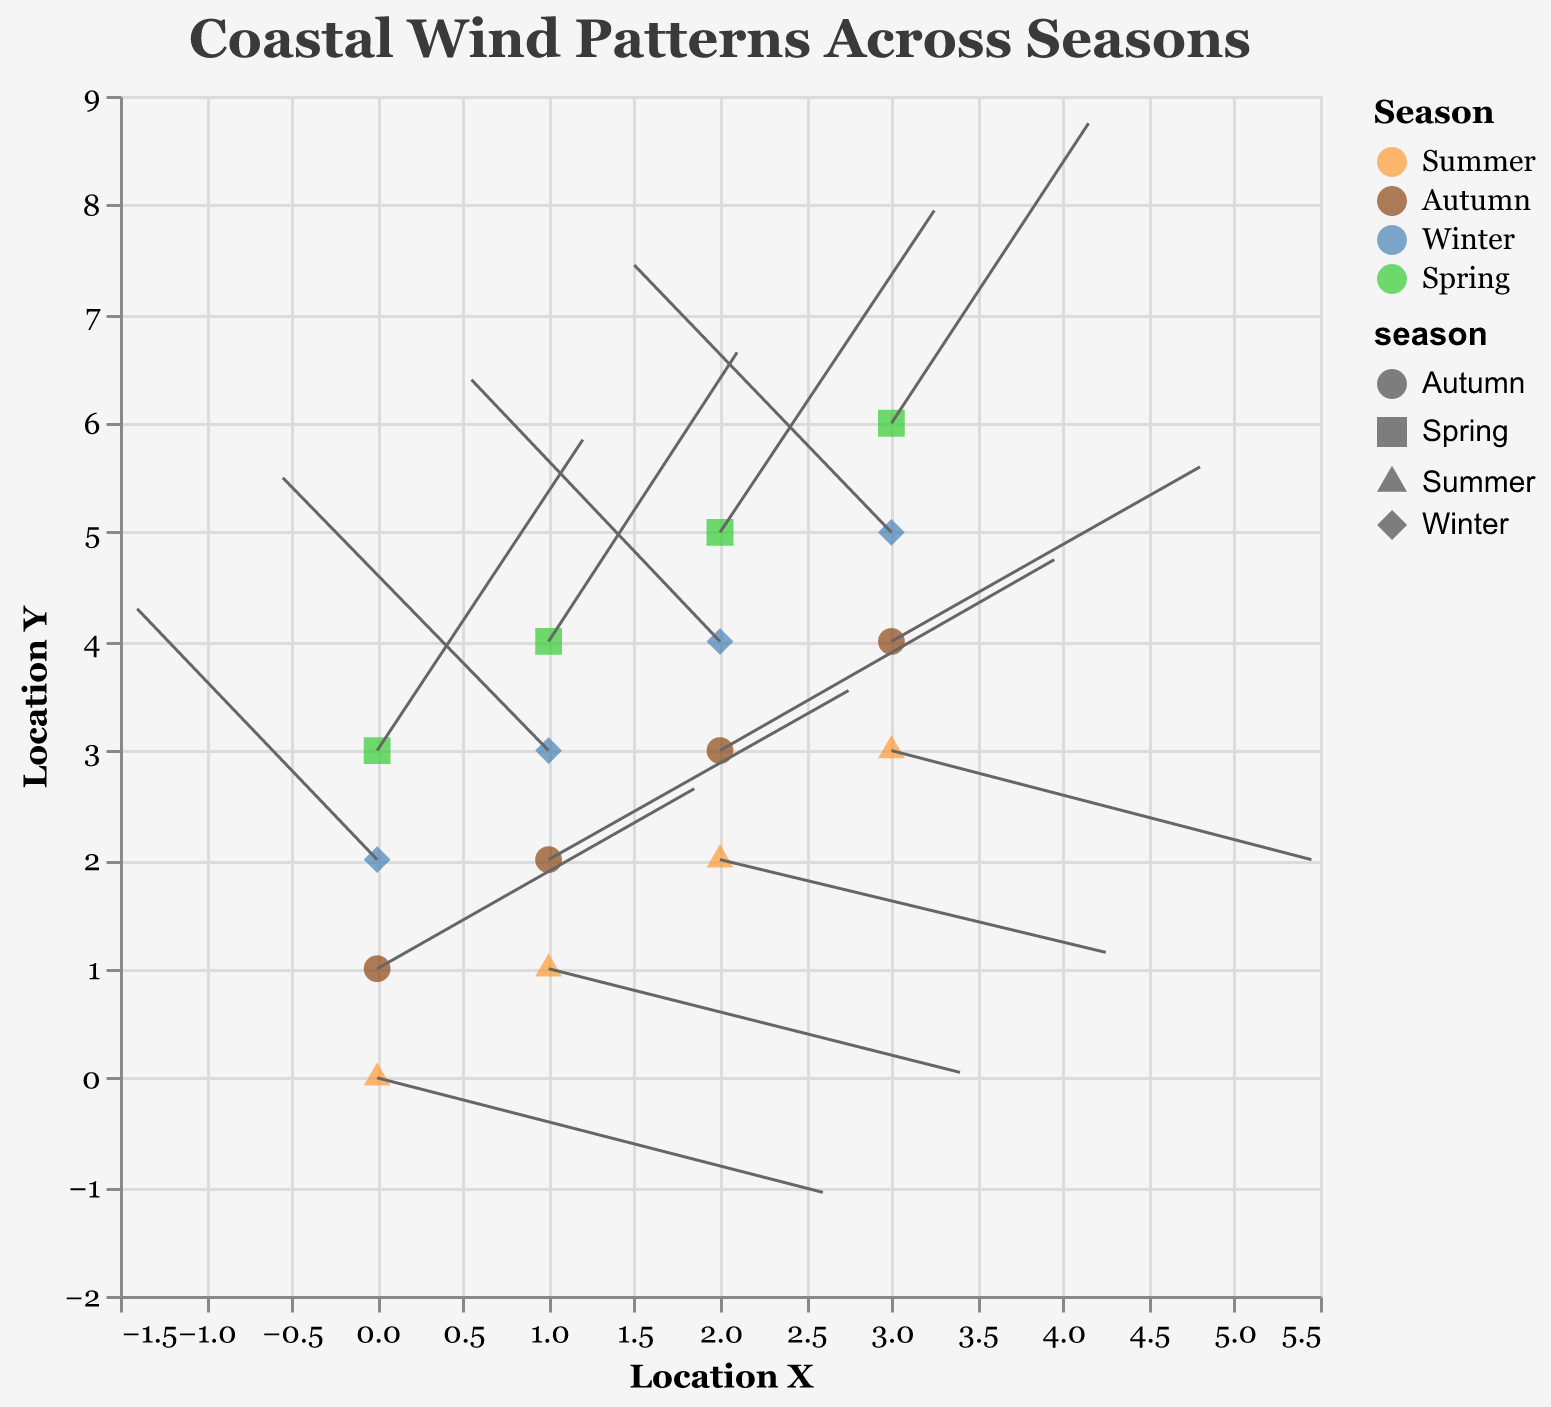What's the title of this quiver plot? The title of a plot is generally displayed at the top center and clearly states what the visual represents.
Answer: Coastal Wind Patterns Across Seasons How many seasons are represented in the plot? By observing the legend, we can see that there are four different markers representing different seasons.
Answer: Four Which season has wind vectors primarily pointing towards the left? By examining the direction of the arrows, we can see that Winter has wind vectors mostly pointing toward the left.
Answer: Winter During which season does wind exhibit both upward and leftward directions? Looking for vectors pointing upwards and to the left, Winter's arrows move in this direction for x starting from 0 to 3.
Answer: Winter How does the wind speed in Spring compare to that in Summer? Compare the lengths of the arrows for Spring (longer arrows) and Summer (shorter arrows), indicating a faster wind speed in Spring.
Answer: Spring has faster winds What are the u and v values of the point at x=0, y=1 in Autumn? The data for Autumn at (0,1) shows the values of u and v are 3.7 and 3.3 respectively.
Answer: u=3.7, v=3.3 Which season has wind vectors that are generally the shortest? By comparing the length of all vectors, Summer has the shortest vectors overall.
Answer: Summer If you were to estimate the average 'u' component of the wind vector in Autumn, what would it be? Autumn has u values of 3.7, 3.5, 3.9, and 3.6. The average of these is (3.7 + 3.5 + 3.9 + 3.6) / 4 = 3.675.
Answer: 3.675 Which coordinates see an intersection of vectors from different seasons? Looking at the start points of the vectors, coordinate (2,4) has vectors from Winter and Spring intersecting.
Answer: (2,4) 